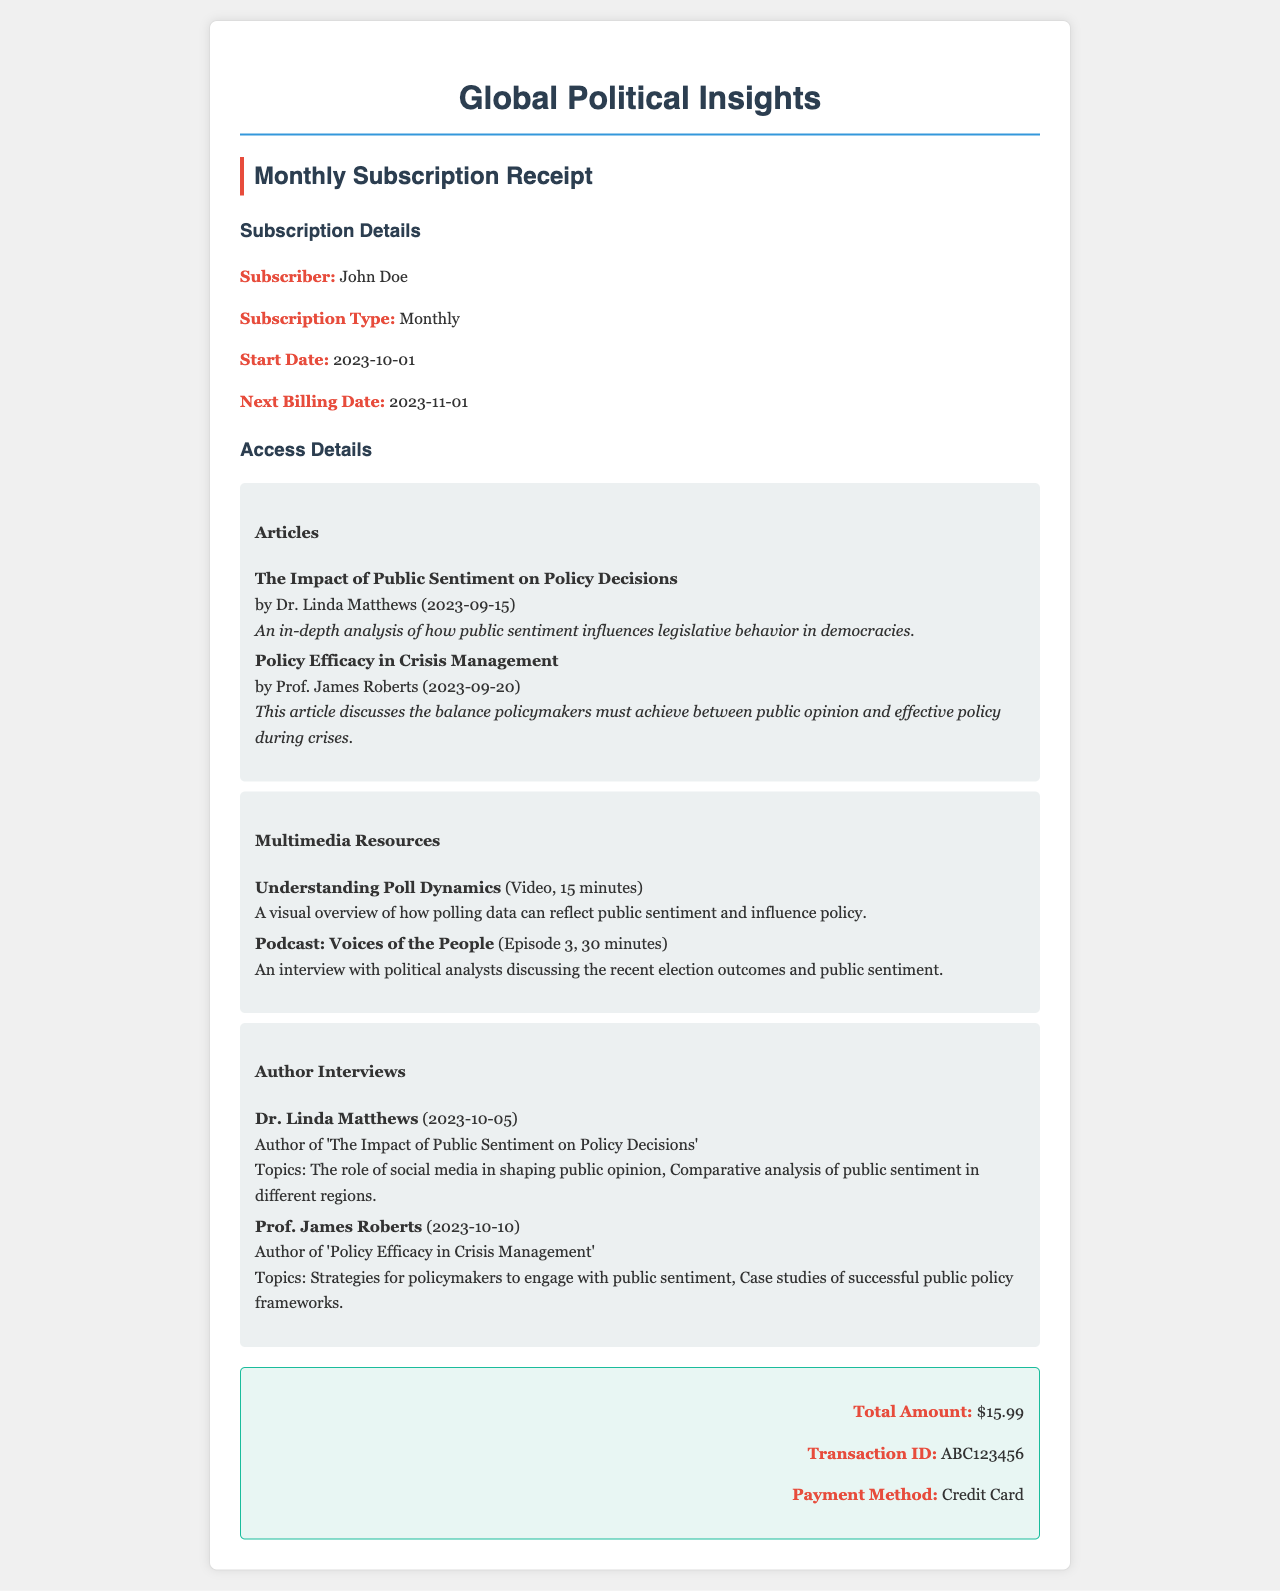What is the subscription type? The subscription type is stated in the document as "Monthly."
Answer: Monthly Who is the subscriber? The document mentions the subscriber's name is "John Doe."
Answer: John Doe When is the next billing date? The next billing date is provided in the subscription details as "2023-11-01."
Answer: 2023-11-01 What is the total amount of the subscription? The total amount for the subscription is clearly stated as "$15.99."
Answer: $15.99 What is the title of the article by Dr. Linda Matthews? The document lists the title of Dr. Linda Matthews's article as "The Impact of Public Sentiment on Policy Decisions."
Answer: The Impact of Public Sentiment on Policy Decisions How long is the video resource? The document specifies that the video resource "Understanding Poll Dynamics" is "15 minutes" long.
Answer: 15 minutes Who is the author of the article on crisis management? The author of the article titled "Policy Efficacy in Crisis Management" is "Prof. James Roberts."
Answer: Prof. James Roberts What topics does Dr. Linda Matthews discuss in her interview? The topics discussed in Dr. Linda Matthews’s interview include "The role of social media in shaping public opinion, Comparative analysis of public sentiment in different regions."
Answer: The role of social media in shaping public opinion, Comparative analysis of public sentiment in different regions What is the payment method used? The document states the payment method used for the transaction is "Credit Card."
Answer: Credit Card 